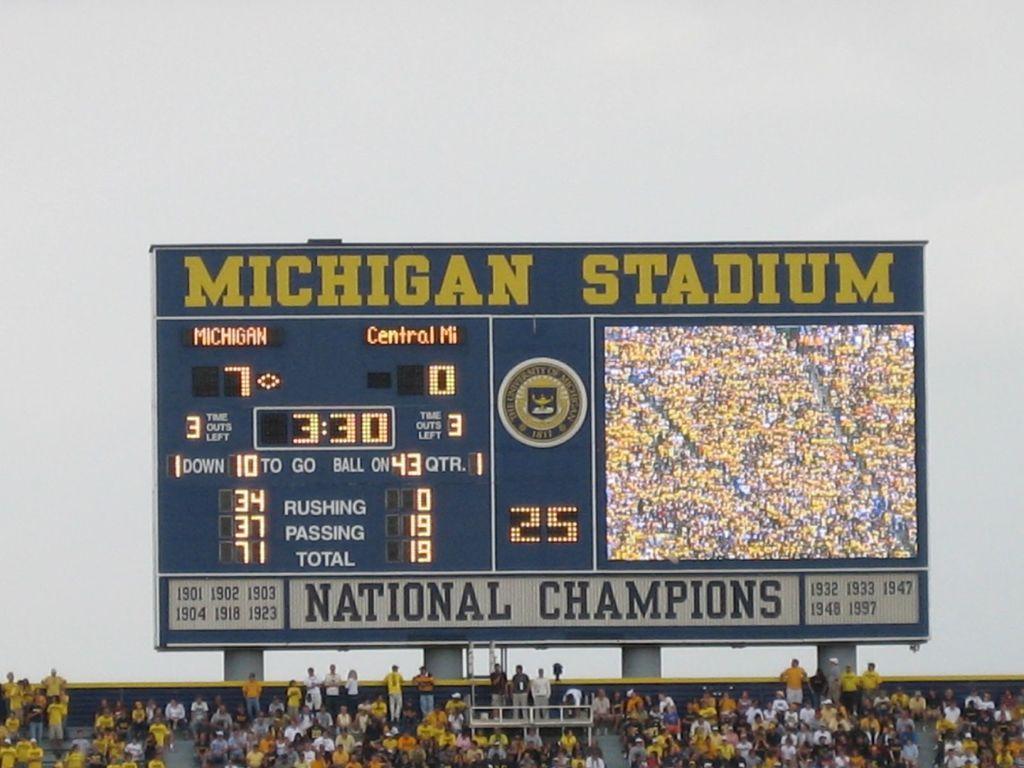How many points up is michigan?
Offer a very short reply. 7. Which stadium is on the sign?
Make the answer very short. Michigan stadium. 